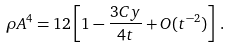<formula> <loc_0><loc_0><loc_500><loc_500>\rho A ^ { 4 } = 1 2 \left [ 1 - \frac { 3 C y } { 4 t } + O ( t ^ { - 2 } ) \right ] \, .</formula> 